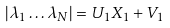Convert formula to latex. <formula><loc_0><loc_0><loc_500><loc_500>| \lambda _ { 1 } \dots \lambda _ { N } | = U _ { 1 } X _ { 1 } + V _ { 1 }</formula> 